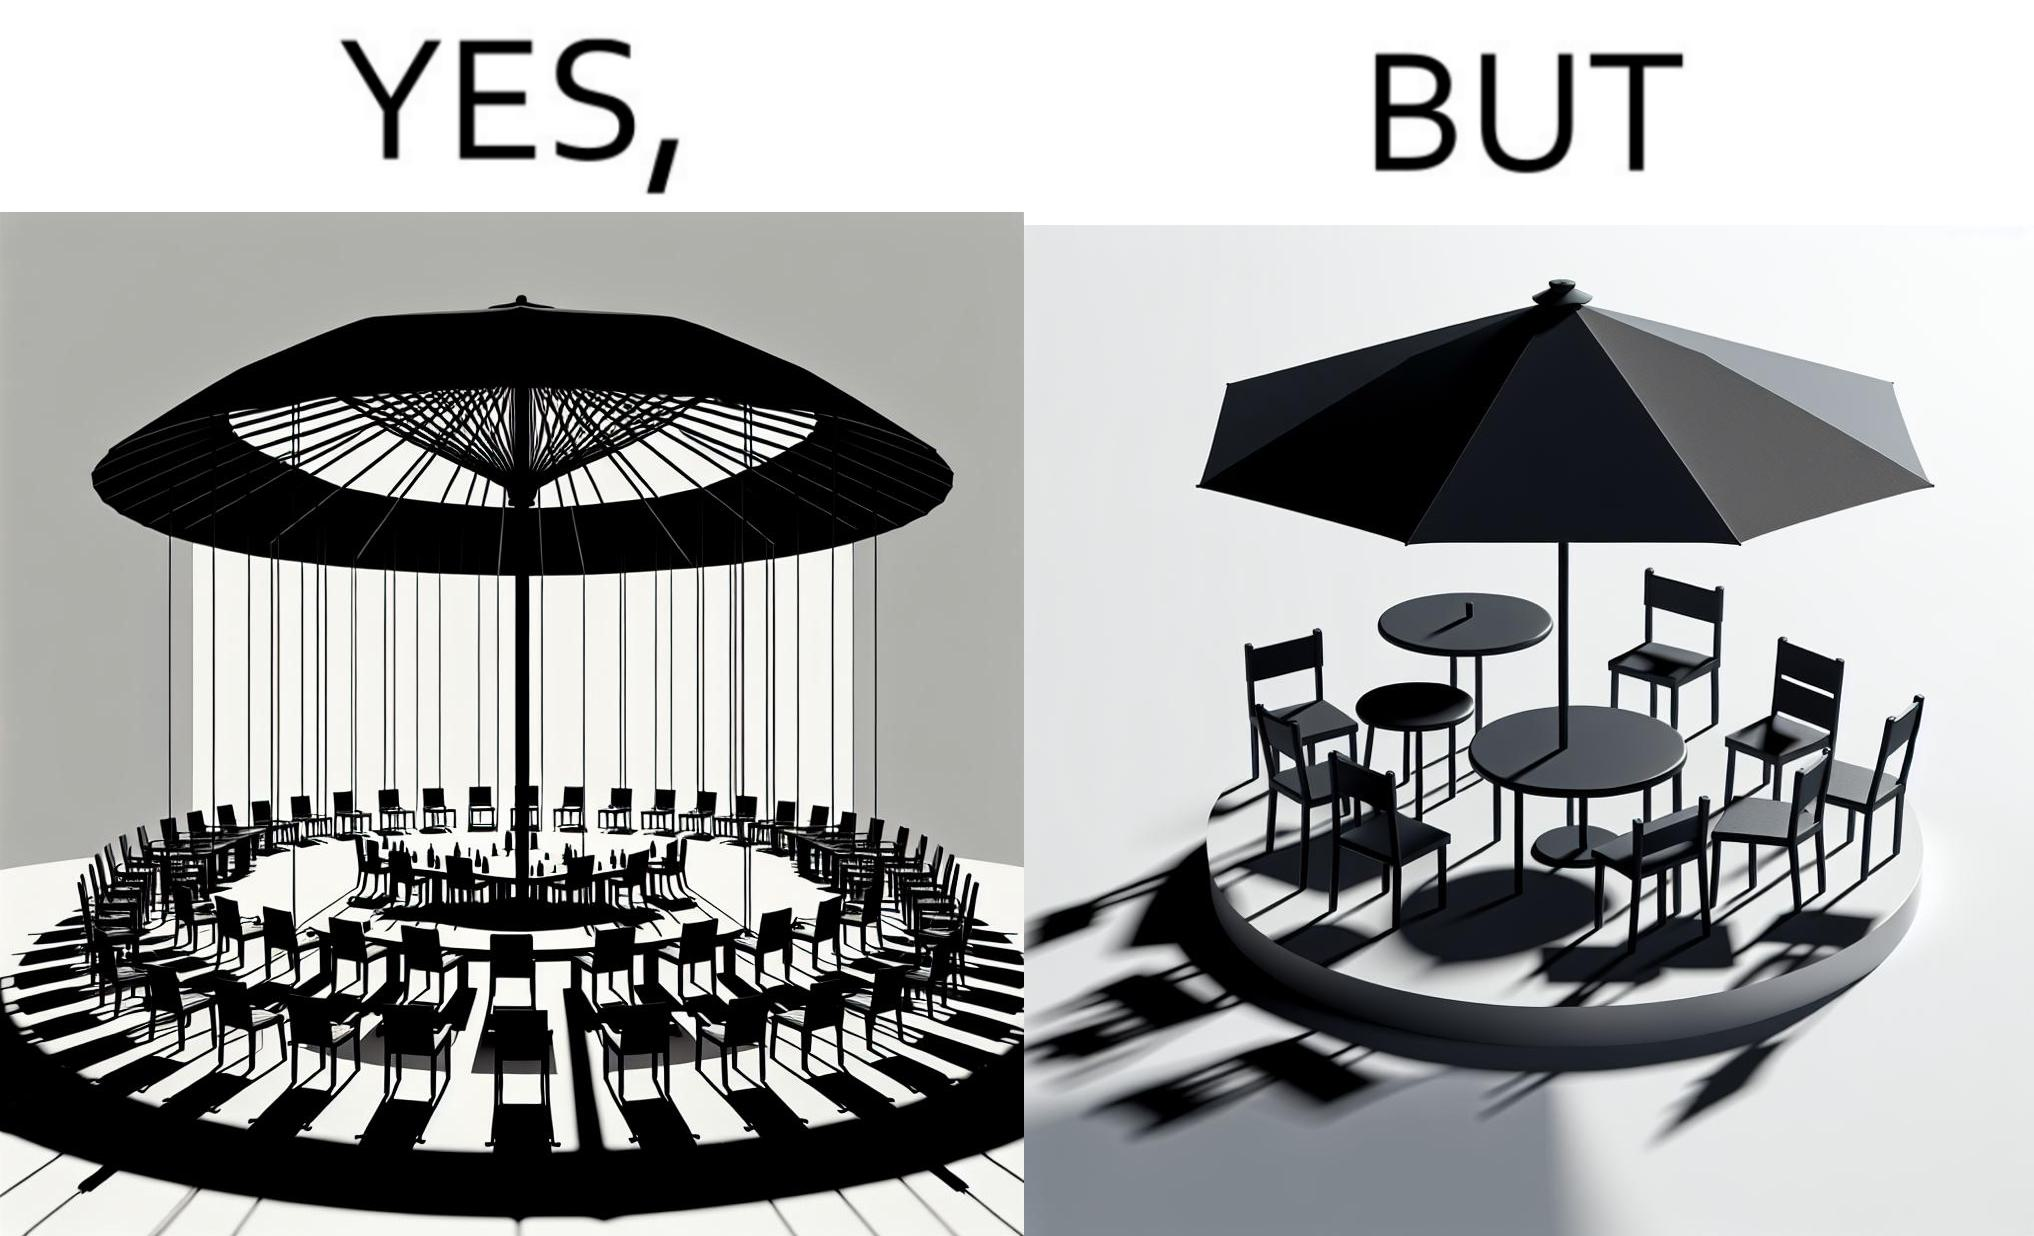Explain why this image is satirical. The image is ironical, as the umbrella is meant to provide shadow in the area where the chairs are present, but due to the orientation of the rays of the sun, all the chairs are in sunlight, and the umbrella is of no use in this situation. 